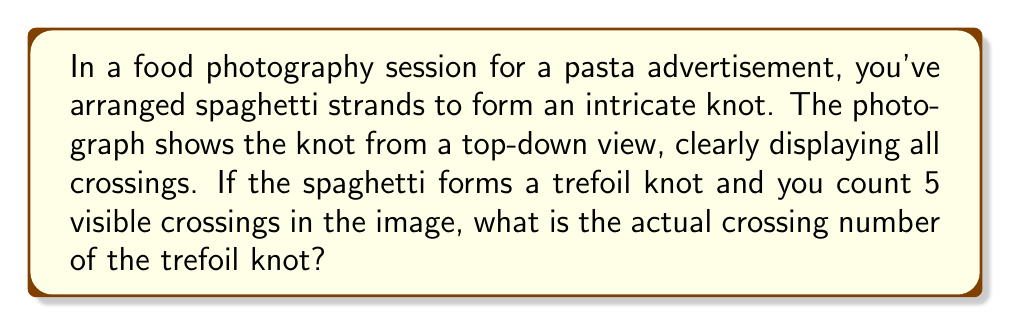Provide a solution to this math problem. Let's approach this step-by-step:

1) First, we need to understand what a crossing number is in knot theory. The crossing number of a knot is the minimum number of crossings that occur in any projection of the knot onto a plane.

2) In this case, we're dealing with a trefoil knot. The trefoil knot is one of the simplest non-trivial knots.

3) The photograph shows 5 crossings, but this doesn't necessarily represent the minimum number of crossings possible for this knot.

4) In knot theory, it's proven that the trefoil knot has a crossing number of 3. This means that in its simplest representation, it will have exactly 3 crossings.

5) The additional crossings in the photograph (5 instead of 3) are likely due to the way the spaghetti is arranged for aesthetic purposes in the food photography.

6) It's important to note that while the photograph shows more crossings, this doesn't change the fundamental topology of the knot. The trefoil knot remains a trefoil knot regardless of how it's arranged or photographed.

7) Therefore, despite the visual representation in the photograph, the actual crossing number of the trefoil knot formed by the spaghetti is still 3.

This concept is crucial in knot theory, where we're interested in the essential properties of knots that don't change under continuous deformations.
Answer: 3 